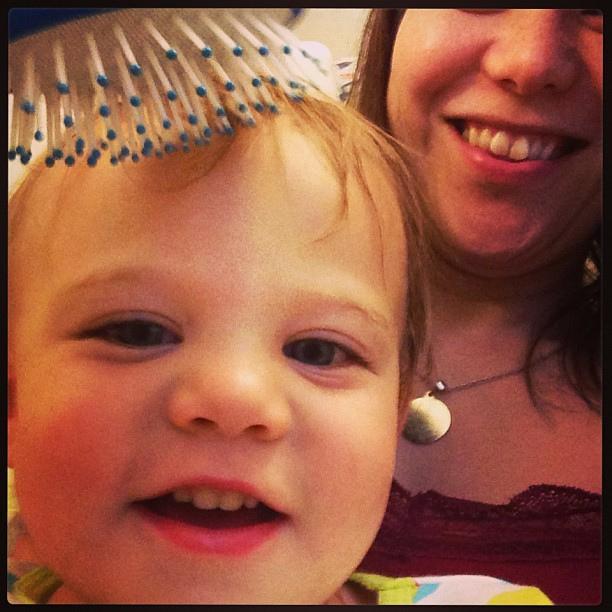How many people are in the picture?
Give a very brief answer. 2. How many butter knives are on the table?
Give a very brief answer. 0. 